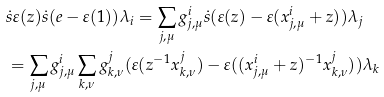Convert formula to latex. <formula><loc_0><loc_0><loc_500><loc_500>& \ \dot { s } \varepsilon ( z ) \dot { s } ( e - \varepsilon ( 1 ) ) \lambda _ { i } = \sum _ { j , \mu } g ^ { i } _ { j , \mu } \dot { s } ( \varepsilon ( z ) - \varepsilon ( x ^ { i } _ { j , \mu } + z ) ) \lambda _ { j } \\ & \ = \sum _ { j , \mu } g ^ { i } _ { j , \mu } \sum _ { k , \nu } g ^ { j } _ { k , \nu } ( \varepsilon ( z ^ { - 1 } x ^ { j } _ { k , \nu } ) - \varepsilon ( ( x ^ { i } _ { j , \mu } + z ) ^ { - 1 } x ^ { j } _ { k , \nu } ) ) \lambda _ { k }</formula> 